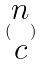Convert formula to latex. <formula><loc_0><loc_0><loc_500><loc_500>( \begin{matrix} n \\ c \end{matrix} )</formula> 